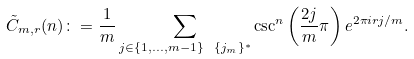Convert formula to latex. <formula><loc_0><loc_0><loc_500><loc_500>\tilde { C } _ { m , r } ( n ) \colon = \frac { 1 } { m } \sum _ { j \in \{ 1 , \dots , m - 1 \} \ \{ j _ { m } \} ^ { \ast } } \csc ^ { n } \left ( \frac { 2 j } { m } \pi \right ) e ^ { 2 \pi i r j / m } .</formula> 